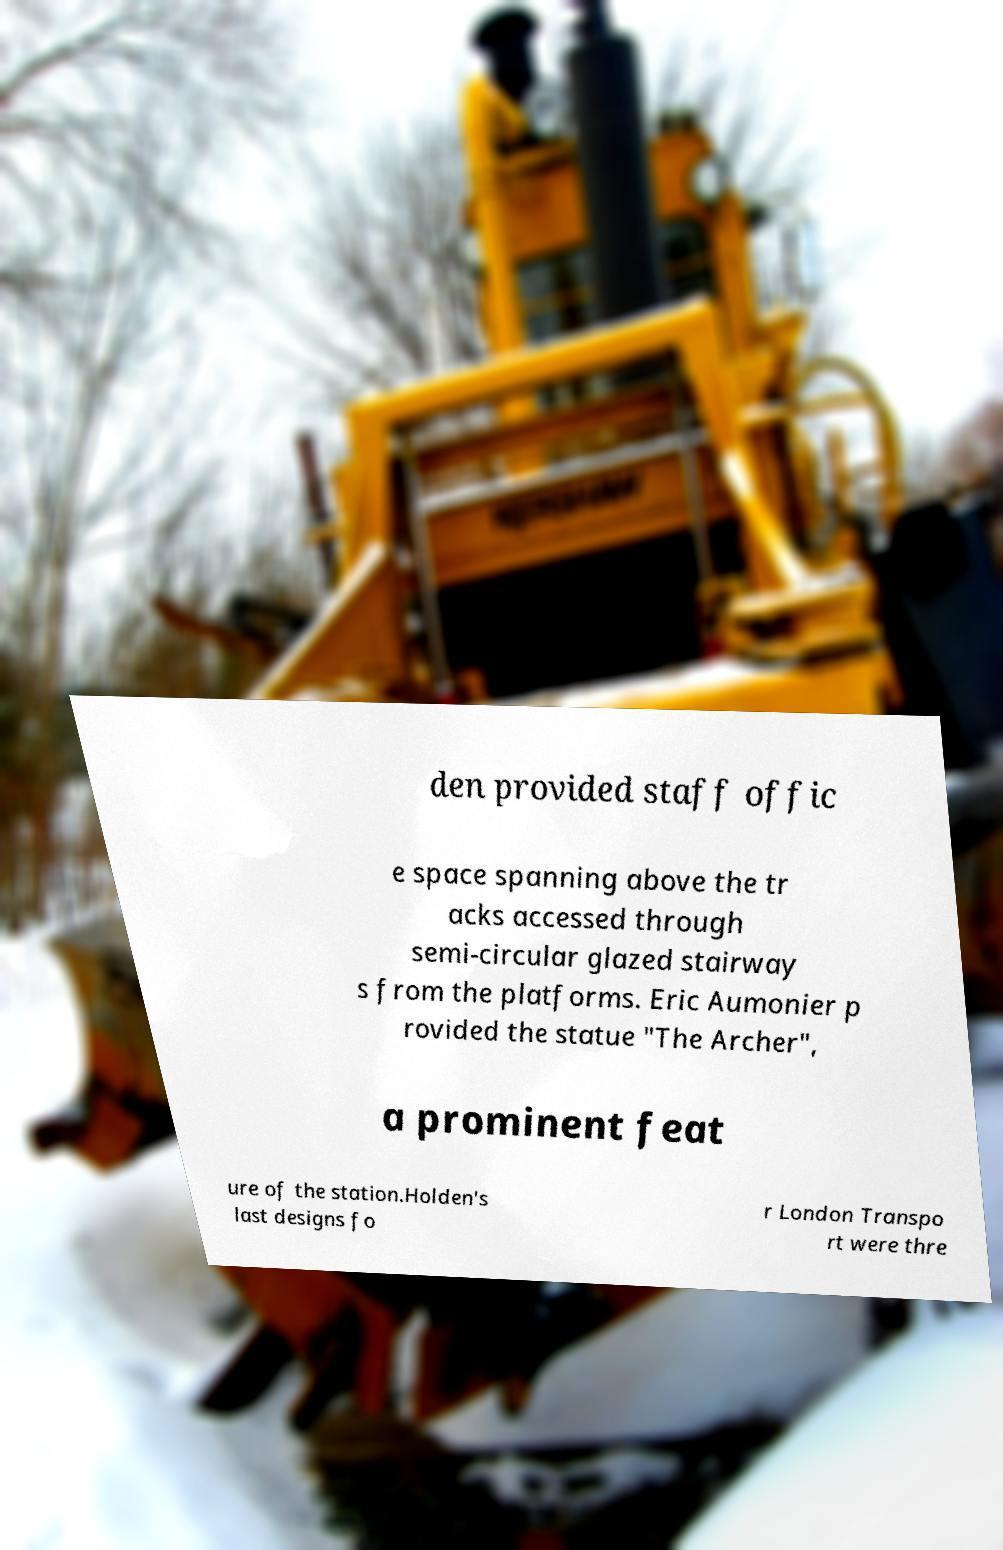Could you extract and type out the text from this image? den provided staff offic e space spanning above the tr acks accessed through semi-circular glazed stairway s from the platforms. Eric Aumonier p rovided the statue "The Archer", a prominent feat ure of the station.Holden's last designs fo r London Transpo rt were thre 